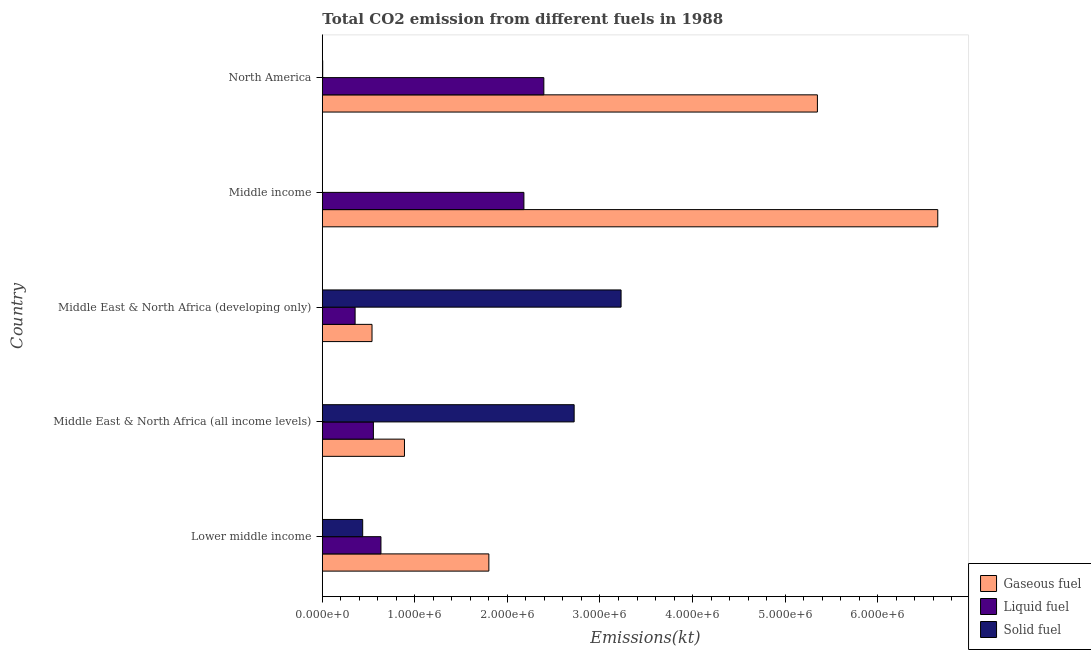How many different coloured bars are there?
Give a very brief answer. 3. How many bars are there on the 5th tick from the top?
Your response must be concise. 3. What is the label of the 3rd group of bars from the top?
Offer a very short reply. Middle East & North Africa (developing only). In how many cases, is the number of bars for a given country not equal to the number of legend labels?
Ensure brevity in your answer.  0. What is the amount of co2 emissions from liquid fuel in Lower middle income?
Provide a succinct answer. 6.33e+05. Across all countries, what is the maximum amount of co2 emissions from gaseous fuel?
Give a very brief answer. 6.65e+06. Across all countries, what is the minimum amount of co2 emissions from solid fuel?
Ensure brevity in your answer.  366.7. In which country was the amount of co2 emissions from liquid fuel maximum?
Your response must be concise. North America. In which country was the amount of co2 emissions from solid fuel minimum?
Your response must be concise. Middle income. What is the total amount of co2 emissions from gaseous fuel in the graph?
Keep it short and to the point. 1.52e+07. What is the difference between the amount of co2 emissions from liquid fuel in Lower middle income and that in Middle income?
Provide a succinct answer. -1.54e+06. What is the difference between the amount of co2 emissions from liquid fuel in Middle East & North Africa (all income levels) and the amount of co2 emissions from gaseous fuel in Lower middle income?
Provide a short and direct response. -1.25e+06. What is the average amount of co2 emissions from liquid fuel per country?
Your answer should be compact. 1.22e+06. What is the difference between the amount of co2 emissions from gaseous fuel and amount of co2 emissions from solid fuel in Middle income?
Your response must be concise. 6.65e+06. In how many countries, is the amount of co2 emissions from solid fuel greater than 600000 kt?
Offer a terse response. 2. What is the ratio of the amount of co2 emissions from solid fuel in Lower middle income to that in Middle East & North Africa (developing only)?
Provide a succinct answer. 0.14. What is the difference between the highest and the second highest amount of co2 emissions from gaseous fuel?
Your answer should be compact. 1.30e+06. What is the difference between the highest and the lowest amount of co2 emissions from liquid fuel?
Provide a short and direct response. 2.04e+06. In how many countries, is the amount of co2 emissions from gaseous fuel greater than the average amount of co2 emissions from gaseous fuel taken over all countries?
Your response must be concise. 2. What does the 3rd bar from the top in Lower middle income represents?
Offer a terse response. Gaseous fuel. What does the 2nd bar from the bottom in Middle income represents?
Provide a short and direct response. Liquid fuel. Is it the case that in every country, the sum of the amount of co2 emissions from gaseous fuel and amount of co2 emissions from liquid fuel is greater than the amount of co2 emissions from solid fuel?
Give a very brief answer. No. Are all the bars in the graph horizontal?
Offer a terse response. Yes. How many countries are there in the graph?
Keep it short and to the point. 5. Does the graph contain any zero values?
Your answer should be compact. No. Does the graph contain grids?
Offer a terse response. No. Where does the legend appear in the graph?
Offer a very short reply. Bottom right. How are the legend labels stacked?
Provide a short and direct response. Vertical. What is the title of the graph?
Keep it short and to the point. Total CO2 emission from different fuels in 1988. What is the label or title of the X-axis?
Make the answer very short. Emissions(kt). What is the label or title of the Y-axis?
Provide a short and direct response. Country. What is the Emissions(kt) of Gaseous fuel in Lower middle income?
Provide a short and direct response. 1.80e+06. What is the Emissions(kt) in Liquid fuel in Lower middle income?
Provide a short and direct response. 6.33e+05. What is the Emissions(kt) in Solid fuel in Lower middle income?
Provide a succinct answer. 4.36e+05. What is the Emissions(kt) of Gaseous fuel in Middle East & North Africa (all income levels)?
Your answer should be very brief. 8.87e+05. What is the Emissions(kt) in Liquid fuel in Middle East & North Africa (all income levels)?
Provide a succinct answer. 5.52e+05. What is the Emissions(kt) of Solid fuel in Middle East & North Africa (all income levels)?
Provide a succinct answer. 2.72e+06. What is the Emissions(kt) of Gaseous fuel in Middle East & North Africa (developing only)?
Offer a terse response. 5.37e+05. What is the Emissions(kt) of Liquid fuel in Middle East & North Africa (developing only)?
Offer a terse response. 3.54e+05. What is the Emissions(kt) in Solid fuel in Middle East & North Africa (developing only)?
Give a very brief answer. 3.23e+06. What is the Emissions(kt) in Gaseous fuel in Middle income?
Offer a terse response. 6.65e+06. What is the Emissions(kt) of Liquid fuel in Middle income?
Offer a very short reply. 2.18e+06. What is the Emissions(kt) of Solid fuel in Middle income?
Provide a succinct answer. 366.7. What is the Emissions(kt) of Gaseous fuel in North America?
Your response must be concise. 5.35e+06. What is the Emissions(kt) of Liquid fuel in North America?
Offer a very short reply. 2.39e+06. What is the Emissions(kt) in Solid fuel in North America?
Offer a very short reply. 4019.03. Across all countries, what is the maximum Emissions(kt) in Gaseous fuel?
Make the answer very short. 6.65e+06. Across all countries, what is the maximum Emissions(kt) in Liquid fuel?
Your response must be concise. 2.39e+06. Across all countries, what is the maximum Emissions(kt) of Solid fuel?
Your answer should be compact. 3.23e+06. Across all countries, what is the minimum Emissions(kt) in Gaseous fuel?
Keep it short and to the point. 5.37e+05. Across all countries, what is the minimum Emissions(kt) in Liquid fuel?
Your answer should be very brief. 3.54e+05. Across all countries, what is the minimum Emissions(kt) in Solid fuel?
Your answer should be compact. 366.7. What is the total Emissions(kt) of Gaseous fuel in the graph?
Provide a succinct answer. 1.52e+07. What is the total Emissions(kt) in Liquid fuel in the graph?
Make the answer very short. 6.11e+06. What is the total Emissions(kt) of Solid fuel in the graph?
Give a very brief answer. 6.39e+06. What is the difference between the Emissions(kt) of Gaseous fuel in Lower middle income and that in Middle East & North Africa (all income levels)?
Keep it short and to the point. 9.12e+05. What is the difference between the Emissions(kt) of Liquid fuel in Lower middle income and that in Middle East & North Africa (all income levels)?
Your answer should be compact. 8.17e+04. What is the difference between the Emissions(kt) of Solid fuel in Lower middle income and that in Middle East & North Africa (all income levels)?
Offer a very short reply. -2.28e+06. What is the difference between the Emissions(kt) of Gaseous fuel in Lower middle income and that in Middle East & North Africa (developing only)?
Make the answer very short. 1.26e+06. What is the difference between the Emissions(kt) of Liquid fuel in Lower middle income and that in Middle East & North Africa (developing only)?
Your answer should be very brief. 2.79e+05. What is the difference between the Emissions(kt) of Solid fuel in Lower middle income and that in Middle East & North Africa (developing only)?
Ensure brevity in your answer.  -2.79e+06. What is the difference between the Emissions(kt) of Gaseous fuel in Lower middle income and that in Middle income?
Your response must be concise. -4.85e+06. What is the difference between the Emissions(kt) of Liquid fuel in Lower middle income and that in Middle income?
Ensure brevity in your answer.  -1.54e+06. What is the difference between the Emissions(kt) of Solid fuel in Lower middle income and that in Middle income?
Offer a very short reply. 4.36e+05. What is the difference between the Emissions(kt) of Gaseous fuel in Lower middle income and that in North America?
Ensure brevity in your answer.  -3.55e+06. What is the difference between the Emissions(kt) in Liquid fuel in Lower middle income and that in North America?
Give a very brief answer. -1.76e+06. What is the difference between the Emissions(kt) in Solid fuel in Lower middle income and that in North America?
Your response must be concise. 4.32e+05. What is the difference between the Emissions(kt) of Gaseous fuel in Middle East & North Africa (all income levels) and that in Middle East & North Africa (developing only)?
Offer a very short reply. 3.51e+05. What is the difference between the Emissions(kt) in Liquid fuel in Middle East & North Africa (all income levels) and that in Middle East & North Africa (developing only)?
Provide a short and direct response. 1.97e+05. What is the difference between the Emissions(kt) of Solid fuel in Middle East & North Africa (all income levels) and that in Middle East & North Africa (developing only)?
Ensure brevity in your answer.  -5.07e+05. What is the difference between the Emissions(kt) in Gaseous fuel in Middle East & North Africa (all income levels) and that in Middle income?
Keep it short and to the point. -5.76e+06. What is the difference between the Emissions(kt) of Liquid fuel in Middle East & North Africa (all income levels) and that in Middle income?
Give a very brief answer. -1.63e+06. What is the difference between the Emissions(kt) of Solid fuel in Middle East & North Africa (all income levels) and that in Middle income?
Offer a terse response. 2.72e+06. What is the difference between the Emissions(kt) of Gaseous fuel in Middle East & North Africa (all income levels) and that in North America?
Keep it short and to the point. -4.46e+06. What is the difference between the Emissions(kt) in Liquid fuel in Middle East & North Africa (all income levels) and that in North America?
Offer a very short reply. -1.84e+06. What is the difference between the Emissions(kt) of Solid fuel in Middle East & North Africa (all income levels) and that in North America?
Your answer should be compact. 2.72e+06. What is the difference between the Emissions(kt) in Gaseous fuel in Middle East & North Africa (developing only) and that in Middle income?
Offer a terse response. -6.11e+06. What is the difference between the Emissions(kt) in Liquid fuel in Middle East & North Africa (developing only) and that in Middle income?
Provide a short and direct response. -1.82e+06. What is the difference between the Emissions(kt) in Solid fuel in Middle East & North Africa (developing only) and that in Middle income?
Offer a terse response. 3.23e+06. What is the difference between the Emissions(kt) in Gaseous fuel in Middle East & North Africa (developing only) and that in North America?
Ensure brevity in your answer.  -4.81e+06. What is the difference between the Emissions(kt) of Liquid fuel in Middle East & North Africa (developing only) and that in North America?
Give a very brief answer. -2.04e+06. What is the difference between the Emissions(kt) of Solid fuel in Middle East & North Africa (developing only) and that in North America?
Provide a succinct answer. 3.22e+06. What is the difference between the Emissions(kt) in Gaseous fuel in Middle income and that in North America?
Ensure brevity in your answer.  1.30e+06. What is the difference between the Emissions(kt) in Liquid fuel in Middle income and that in North America?
Make the answer very short. -2.15e+05. What is the difference between the Emissions(kt) in Solid fuel in Middle income and that in North America?
Your response must be concise. -3652.33. What is the difference between the Emissions(kt) of Gaseous fuel in Lower middle income and the Emissions(kt) of Liquid fuel in Middle East & North Africa (all income levels)?
Your answer should be compact. 1.25e+06. What is the difference between the Emissions(kt) in Gaseous fuel in Lower middle income and the Emissions(kt) in Solid fuel in Middle East & North Africa (all income levels)?
Ensure brevity in your answer.  -9.22e+05. What is the difference between the Emissions(kt) in Liquid fuel in Lower middle income and the Emissions(kt) in Solid fuel in Middle East & North Africa (all income levels)?
Offer a very short reply. -2.09e+06. What is the difference between the Emissions(kt) in Gaseous fuel in Lower middle income and the Emissions(kt) in Liquid fuel in Middle East & North Africa (developing only)?
Offer a very short reply. 1.45e+06. What is the difference between the Emissions(kt) of Gaseous fuel in Lower middle income and the Emissions(kt) of Solid fuel in Middle East & North Africa (developing only)?
Ensure brevity in your answer.  -1.43e+06. What is the difference between the Emissions(kt) in Liquid fuel in Lower middle income and the Emissions(kt) in Solid fuel in Middle East & North Africa (developing only)?
Ensure brevity in your answer.  -2.59e+06. What is the difference between the Emissions(kt) of Gaseous fuel in Lower middle income and the Emissions(kt) of Liquid fuel in Middle income?
Your answer should be compact. -3.79e+05. What is the difference between the Emissions(kt) of Gaseous fuel in Lower middle income and the Emissions(kt) of Solid fuel in Middle income?
Offer a terse response. 1.80e+06. What is the difference between the Emissions(kt) in Liquid fuel in Lower middle income and the Emissions(kt) in Solid fuel in Middle income?
Provide a short and direct response. 6.33e+05. What is the difference between the Emissions(kt) of Gaseous fuel in Lower middle income and the Emissions(kt) of Liquid fuel in North America?
Offer a very short reply. -5.94e+05. What is the difference between the Emissions(kt) of Gaseous fuel in Lower middle income and the Emissions(kt) of Solid fuel in North America?
Provide a short and direct response. 1.80e+06. What is the difference between the Emissions(kt) in Liquid fuel in Lower middle income and the Emissions(kt) in Solid fuel in North America?
Your answer should be very brief. 6.29e+05. What is the difference between the Emissions(kt) in Gaseous fuel in Middle East & North Africa (all income levels) and the Emissions(kt) in Liquid fuel in Middle East & North Africa (developing only)?
Give a very brief answer. 5.33e+05. What is the difference between the Emissions(kt) in Gaseous fuel in Middle East & North Africa (all income levels) and the Emissions(kt) in Solid fuel in Middle East & North Africa (developing only)?
Provide a short and direct response. -2.34e+06. What is the difference between the Emissions(kt) of Liquid fuel in Middle East & North Africa (all income levels) and the Emissions(kt) of Solid fuel in Middle East & North Africa (developing only)?
Offer a very short reply. -2.68e+06. What is the difference between the Emissions(kt) in Gaseous fuel in Middle East & North Africa (all income levels) and the Emissions(kt) in Liquid fuel in Middle income?
Keep it short and to the point. -1.29e+06. What is the difference between the Emissions(kt) of Gaseous fuel in Middle East & North Africa (all income levels) and the Emissions(kt) of Solid fuel in Middle income?
Ensure brevity in your answer.  8.87e+05. What is the difference between the Emissions(kt) of Liquid fuel in Middle East & North Africa (all income levels) and the Emissions(kt) of Solid fuel in Middle income?
Offer a terse response. 5.51e+05. What is the difference between the Emissions(kt) of Gaseous fuel in Middle East & North Africa (all income levels) and the Emissions(kt) of Liquid fuel in North America?
Your response must be concise. -1.51e+06. What is the difference between the Emissions(kt) in Gaseous fuel in Middle East & North Africa (all income levels) and the Emissions(kt) in Solid fuel in North America?
Your answer should be compact. 8.83e+05. What is the difference between the Emissions(kt) in Liquid fuel in Middle East & North Africa (all income levels) and the Emissions(kt) in Solid fuel in North America?
Give a very brief answer. 5.48e+05. What is the difference between the Emissions(kt) of Gaseous fuel in Middle East & North Africa (developing only) and the Emissions(kt) of Liquid fuel in Middle income?
Give a very brief answer. -1.64e+06. What is the difference between the Emissions(kt) of Gaseous fuel in Middle East & North Africa (developing only) and the Emissions(kt) of Solid fuel in Middle income?
Your answer should be very brief. 5.37e+05. What is the difference between the Emissions(kt) in Liquid fuel in Middle East & North Africa (developing only) and the Emissions(kt) in Solid fuel in Middle income?
Give a very brief answer. 3.54e+05. What is the difference between the Emissions(kt) of Gaseous fuel in Middle East & North Africa (developing only) and the Emissions(kt) of Liquid fuel in North America?
Your answer should be compact. -1.86e+06. What is the difference between the Emissions(kt) of Gaseous fuel in Middle East & North Africa (developing only) and the Emissions(kt) of Solid fuel in North America?
Ensure brevity in your answer.  5.33e+05. What is the difference between the Emissions(kt) in Liquid fuel in Middle East & North Africa (developing only) and the Emissions(kt) in Solid fuel in North America?
Provide a short and direct response. 3.50e+05. What is the difference between the Emissions(kt) of Gaseous fuel in Middle income and the Emissions(kt) of Liquid fuel in North America?
Offer a very short reply. 4.26e+06. What is the difference between the Emissions(kt) of Gaseous fuel in Middle income and the Emissions(kt) of Solid fuel in North America?
Provide a succinct answer. 6.65e+06. What is the difference between the Emissions(kt) in Liquid fuel in Middle income and the Emissions(kt) in Solid fuel in North America?
Your response must be concise. 2.17e+06. What is the average Emissions(kt) of Gaseous fuel per country?
Make the answer very short. 3.04e+06. What is the average Emissions(kt) in Liquid fuel per country?
Keep it short and to the point. 1.22e+06. What is the average Emissions(kt) in Solid fuel per country?
Ensure brevity in your answer.  1.28e+06. What is the difference between the Emissions(kt) in Gaseous fuel and Emissions(kt) in Liquid fuel in Lower middle income?
Your answer should be compact. 1.17e+06. What is the difference between the Emissions(kt) of Gaseous fuel and Emissions(kt) of Solid fuel in Lower middle income?
Provide a short and direct response. 1.36e+06. What is the difference between the Emissions(kt) in Liquid fuel and Emissions(kt) in Solid fuel in Lower middle income?
Offer a very short reply. 1.97e+05. What is the difference between the Emissions(kt) of Gaseous fuel and Emissions(kt) of Liquid fuel in Middle East & North Africa (all income levels)?
Your response must be concise. 3.36e+05. What is the difference between the Emissions(kt) of Gaseous fuel and Emissions(kt) of Solid fuel in Middle East & North Africa (all income levels)?
Provide a succinct answer. -1.83e+06. What is the difference between the Emissions(kt) in Liquid fuel and Emissions(kt) in Solid fuel in Middle East & North Africa (all income levels)?
Provide a short and direct response. -2.17e+06. What is the difference between the Emissions(kt) in Gaseous fuel and Emissions(kt) in Liquid fuel in Middle East & North Africa (developing only)?
Give a very brief answer. 1.83e+05. What is the difference between the Emissions(kt) in Gaseous fuel and Emissions(kt) in Solid fuel in Middle East & North Africa (developing only)?
Provide a succinct answer. -2.69e+06. What is the difference between the Emissions(kt) of Liquid fuel and Emissions(kt) of Solid fuel in Middle East & North Africa (developing only)?
Make the answer very short. -2.87e+06. What is the difference between the Emissions(kt) of Gaseous fuel and Emissions(kt) of Liquid fuel in Middle income?
Ensure brevity in your answer.  4.47e+06. What is the difference between the Emissions(kt) of Gaseous fuel and Emissions(kt) of Solid fuel in Middle income?
Your response must be concise. 6.65e+06. What is the difference between the Emissions(kt) of Liquid fuel and Emissions(kt) of Solid fuel in Middle income?
Ensure brevity in your answer.  2.18e+06. What is the difference between the Emissions(kt) in Gaseous fuel and Emissions(kt) in Liquid fuel in North America?
Your answer should be compact. 2.96e+06. What is the difference between the Emissions(kt) of Gaseous fuel and Emissions(kt) of Solid fuel in North America?
Make the answer very short. 5.35e+06. What is the difference between the Emissions(kt) in Liquid fuel and Emissions(kt) in Solid fuel in North America?
Offer a very short reply. 2.39e+06. What is the ratio of the Emissions(kt) of Gaseous fuel in Lower middle income to that in Middle East & North Africa (all income levels)?
Offer a terse response. 2.03. What is the ratio of the Emissions(kt) of Liquid fuel in Lower middle income to that in Middle East & North Africa (all income levels)?
Your response must be concise. 1.15. What is the ratio of the Emissions(kt) of Solid fuel in Lower middle income to that in Middle East & North Africa (all income levels)?
Provide a succinct answer. 0.16. What is the ratio of the Emissions(kt) in Gaseous fuel in Lower middle income to that in Middle East & North Africa (developing only)?
Your response must be concise. 3.35. What is the ratio of the Emissions(kt) in Liquid fuel in Lower middle income to that in Middle East & North Africa (developing only)?
Your response must be concise. 1.79. What is the ratio of the Emissions(kt) of Solid fuel in Lower middle income to that in Middle East & North Africa (developing only)?
Your response must be concise. 0.14. What is the ratio of the Emissions(kt) of Gaseous fuel in Lower middle income to that in Middle income?
Your answer should be very brief. 0.27. What is the ratio of the Emissions(kt) in Liquid fuel in Lower middle income to that in Middle income?
Offer a very short reply. 0.29. What is the ratio of the Emissions(kt) in Solid fuel in Lower middle income to that in Middle income?
Ensure brevity in your answer.  1188.96. What is the ratio of the Emissions(kt) of Gaseous fuel in Lower middle income to that in North America?
Offer a terse response. 0.34. What is the ratio of the Emissions(kt) of Liquid fuel in Lower middle income to that in North America?
Keep it short and to the point. 0.26. What is the ratio of the Emissions(kt) of Solid fuel in Lower middle income to that in North America?
Your response must be concise. 108.48. What is the ratio of the Emissions(kt) in Gaseous fuel in Middle East & North Africa (all income levels) to that in Middle East & North Africa (developing only)?
Your answer should be very brief. 1.65. What is the ratio of the Emissions(kt) in Liquid fuel in Middle East & North Africa (all income levels) to that in Middle East & North Africa (developing only)?
Your answer should be very brief. 1.56. What is the ratio of the Emissions(kt) of Solid fuel in Middle East & North Africa (all income levels) to that in Middle East & North Africa (developing only)?
Give a very brief answer. 0.84. What is the ratio of the Emissions(kt) in Gaseous fuel in Middle East & North Africa (all income levels) to that in Middle income?
Offer a very short reply. 0.13. What is the ratio of the Emissions(kt) in Liquid fuel in Middle East & North Africa (all income levels) to that in Middle income?
Keep it short and to the point. 0.25. What is the ratio of the Emissions(kt) in Solid fuel in Middle East & North Africa (all income levels) to that in Middle income?
Your answer should be very brief. 7419.92. What is the ratio of the Emissions(kt) in Gaseous fuel in Middle East & North Africa (all income levels) to that in North America?
Your answer should be compact. 0.17. What is the ratio of the Emissions(kt) in Liquid fuel in Middle East & North Africa (all income levels) to that in North America?
Your response must be concise. 0.23. What is the ratio of the Emissions(kt) of Solid fuel in Middle East & North Africa (all income levels) to that in North America?
Offer a terse response. 677. What is the ratio of the Emissions(kt) of Gaseous fuel in Middle East & North Africa (developing only) to that in Middle income?
Make the answer very short. 0.08. What is the ratio of the Emissions(kt) of Liquid fuel in Middle East & North Africa (developing only) to that in Middle income?
Provide a succinct answer. 0.16. What is the ratio of the Emissions(kt) in Solid fuel in Middle East & North Africa (developing only) to that in Middle income?
Your answer should be very brief. 8802.4. What is the ratio of the Emissions(kt) of Gaseous fuel in Middle East & North Africa (developing only) to that in North America?
Give a very brief answer. 0.1. What is the ratio of the Emissions(kt) in Liquid fuel in Middle East & North Africa (developing only) to that in North America?
Make the answer very short. 0.15. What is the ratio of the Emissions(kt) of Solid fuel in Middle East & North Africa (developing only) to that in North America?
Your answer should be very brief. 803.14. What is the ratio of the Emissions(kt) in Gaseous fuel in Middle income to that in North America?
Make the answer very short. 1.24. What is the ratio of the Emissions(kt) in Liquid fuel in Middle income to that in North America?
Your answer should be very brief. 0.91. What is the ratio of the Emissions(kt) in Solid fuel in Middle income to that in North America?
Your answer should be compact. 0.09. What is the difference between the highest and the second highest Emissions(kt) in Gaseous fuel?
Your answer should be very brief. 1.30e+06. What is the difference between the highest and the second highest Emissions(kt) of Liquid fuel?
Your answer should be compact. 2.15e+05. What is the difference between the highest and the second highest Emissions(kt) in Solid fuel?
Provide a succinct answer. 5.07e+05. What is the difference between the highest and the lowest Emissions(kt) in Gaseous fuel?
Ensure brevity in your answer.  6.11e+06. What is the difference between the highest and the lowest Emissions(kt) in Liquid fuel?
Offer a very short reply. 2.04e+06. What is the difference between the highest and the lowest Emissions(kt) of Solid fuel?
Your answer should be very brief. 3.23e+06. 